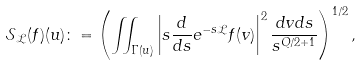<formula> <loc_0><loc_0><loc_500><loc_500>\mathcal { S } _ { \mathcal { L } } ( f ) ( u ) \colon = \left ( \iint _ { \Gamma ( u ) } \left | s \frac { d } { d s } e ^ { - s \mathcal { L } } f ( v ) \right | ^ { 2 } \frac { d v d s } { s ^ { Q / 2 + 1 } } \right ) ^ { 1 / 2 } ,</formula> 